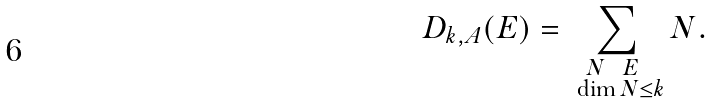<formula> <loc_0><loc_0><loc_500><loc_500>D _ { k , A } ( E ) = \sum _ { \substack { N \ \ E \ \\ \ \dim N \leq k } } N .</formula> 